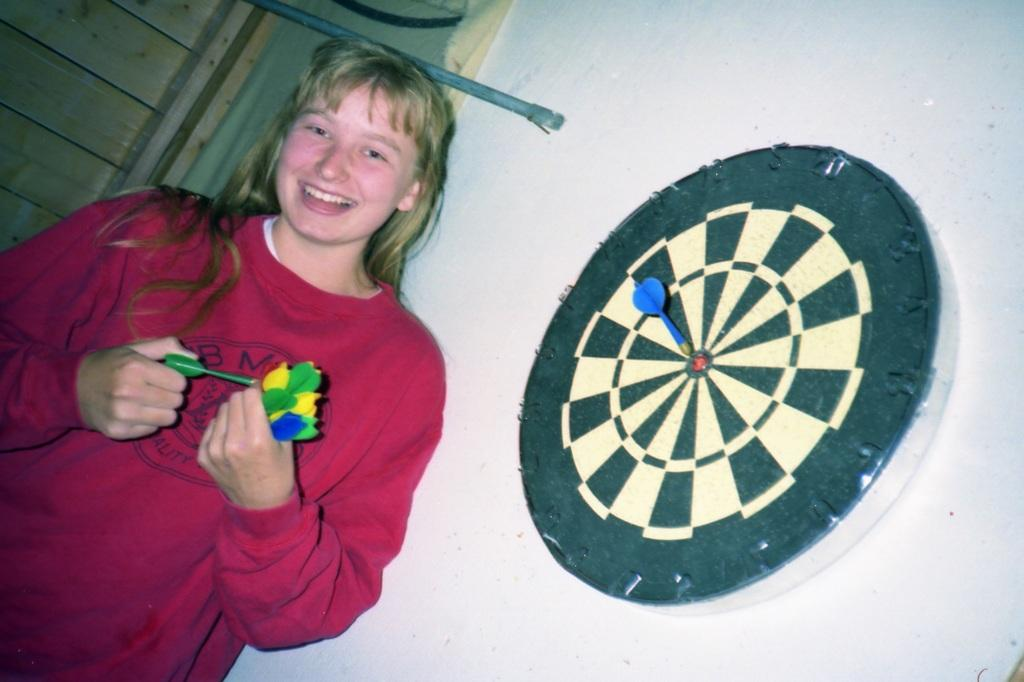What is the woman doing in the image? The woman is holding darts in the image. What is her facial expression? The woman is smiling in the image. What is located on the wall beside the woman? There is a dart board on the wall beside the woman. What type of peace symbol can be seen on the woman's chin in the image? There is no peace symbol or any symbol on the woman's chin in the image. Can you tell me how many giraffes are present in the image? There are no giraffes present in the image. 